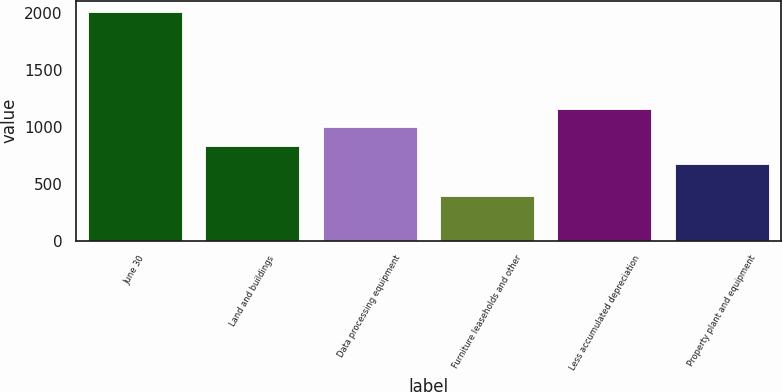Convert chart to OTSL. <chart><loc_0><loc_0><loc_500><loc_500><bar_chart><fcel>June 30<fcel>Land and buildings<fcel>Data processing equipment<fcel>Furniture leaseholds and other<fcel>Less accumulated depreciation<fcel>Property plant and equipment<nl><fcel>2010<fcel>835.06<fcel>996.32<fcel>397.4<fcel>1157.58<fcel>673.8<nl></chart> 